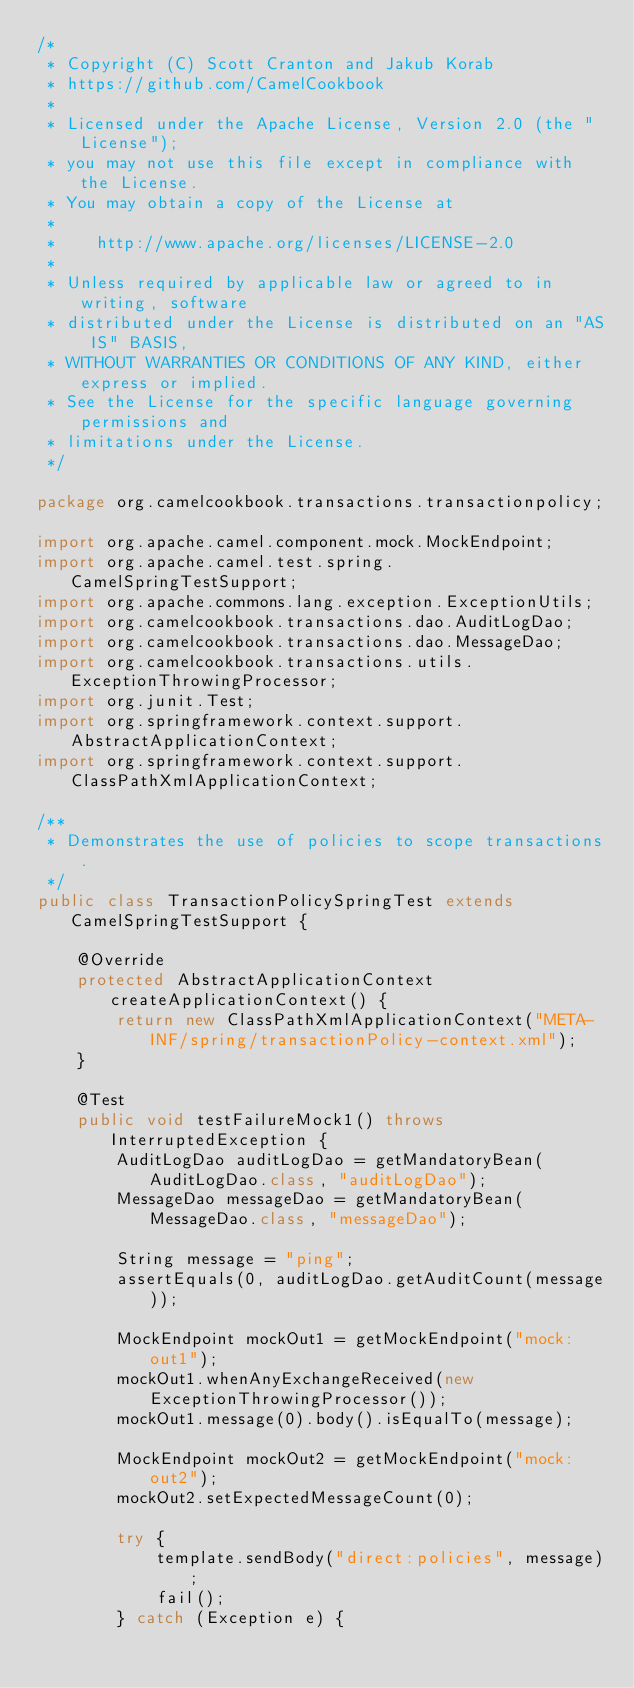Convert code to text. <code><loc_0><loc_0><loc_500><loc_500><_Java_>/*
 * Copyright (C) Scott Cranton and Jakub Korab
 * https://github.com/CamelCookbook
 *
 * Licensed under the Apache License, Version 2.0 (the "License");
 * you may not use this file except in compliance with the License.
 * You may obtain a copy of the License at
 *
 *    http://www.apache.org/licenses/LICENSE-2.0
 *
 * Unless required by applicable law or agreed to in writing, software
 * distributed under the License is distributed on an "AS IS" BASIS,
 * WITHOUT WARRANTIES OR CONDITIONS OF ANY KIND, either express or implied.
 * See the License for the specific language governing permissions and
 * limitations under the License.
 */

package org.camelcookbook.transactions.transactionpolicy;

import org.apache.camel.component.mock.MockEndpoint;
import org.apache.camel.test.spring.CamelSpringTestSupport;
import org.apache.commons.lang.exception.ExceptionUtils;
import org.camelcookbook.transactions.dao.AuditLogDao;
import org.camelcookbook.transactions.dao.MessageDao;
import org.camelcookbook.transactions.utils.ExceptionThrowingProcessor;
import org.junit.Test;
import org.springframework.context.support.AbstractApplicationContext;
import org.springframework.context.support.ClassPathXmlApplicationContext;

/**
 * Demonstrates the use of policies to scope transactions.
 */
public class TransactionPolicySpringTest extends CamelSpringTestSupport {

    @Override
    protected AbstractApplicationContext createApplicationContext() {
        return new ClassPathXmlApplicationContext("META-INF/spring/transactionPolicy-context.xml");
    }

    @Test
    public void testFailureMock1() throws InterruptedException {
        AuditLogDao auditLogDao = getMandatoryBean(AuditLogDao.class, "auditLogDao");
        MessageDao messageDao = getMandatoryBean(MessageDao.class, "messageDao");

        String message = "ping";
        assertEquals(0, auditLogDao.getAuditCount(message));

        MockEndpoint mockOut1 = getMockEndpoint("mock:out1");
        mockOut1.whenAnyExchangeReceived(new ExceptionThrowingProcessor());
        mockOut1.message(0).body().isEqualTo(message);

        MockEndpoint mockOut2 = getMockEndpoint("mock:out2");
        mockOut2.setExpectedMessageCount(0);

        try {
            template.sendBody("direct:policies", message);
            fail();
        } catch (Exception e) {</code> 